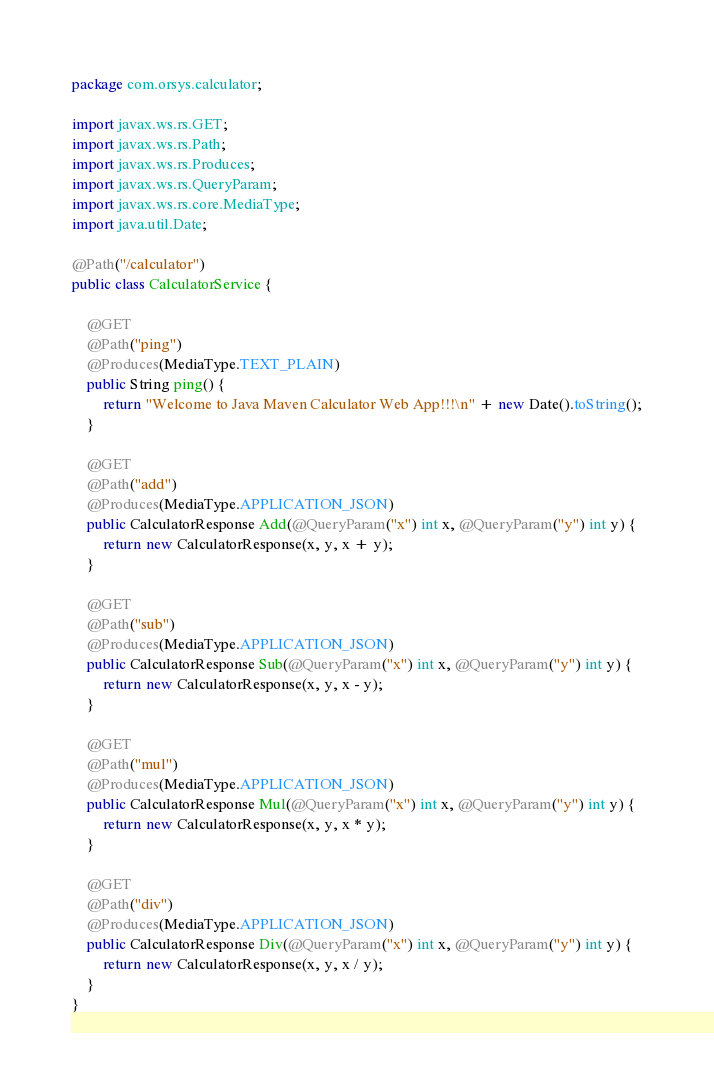Convert code to text. <code><loc_0><loc_0><loc_500><loc_500><_Java_>package com.orsys.calculator;

import javax.ws.rs.GET;
import javax.ws.rs.Path;
import javax.ws.rs.Produces;
import javax.ws.rs.QueryParam;
import javax.ws.rs.core.MediaType;
import java.util.Date;

@Path("/calculator")
public class CalculatorService {

    @GET
    @Path("ping")
    @Produces(MediaType.TEXT_PLAIN)
    public String ping() {
        return "Welcome to Java Maven Calculator Web App!!!\n" + new Date().toString();
    }

    @GET
    @Path("add")
    @Produces(MediaType.APPLICATION_JSON)
    public CalculatorResponse Add(@QueryParam("x") int x, @QueryParam("y") int y) {
        return new CalculatorResponse(x, y, x + y);
    }

    @GET
    @Path("sub")
    @Produces(MediaType.APPLICATION_JSON)
    public CalculatorResponse Sub(@QueryParam("x") int x, @QueryParam("y") int y) {
        return new CalculatorResponse(x, y, x - y);
    }

    @GET
    @Path("mul")
    @Produces(MediaType.APPLICATION_JSON)
    public CalculatorResponse Mul(@QueryParam("x") int x, @QueryParam("y") int y) {
        return new CalculatorResponse(x, y, x * y);
    }

    @GET
    @Path("div")
    @Produces(MediaType.APPLICATION_JSON)
    public CalculatorResponse Div(@QueryParam("x") int x, @QueryParam("y") int y) {
        return new CalculatorResponse(x, y, x / y);
    }
}</code> 